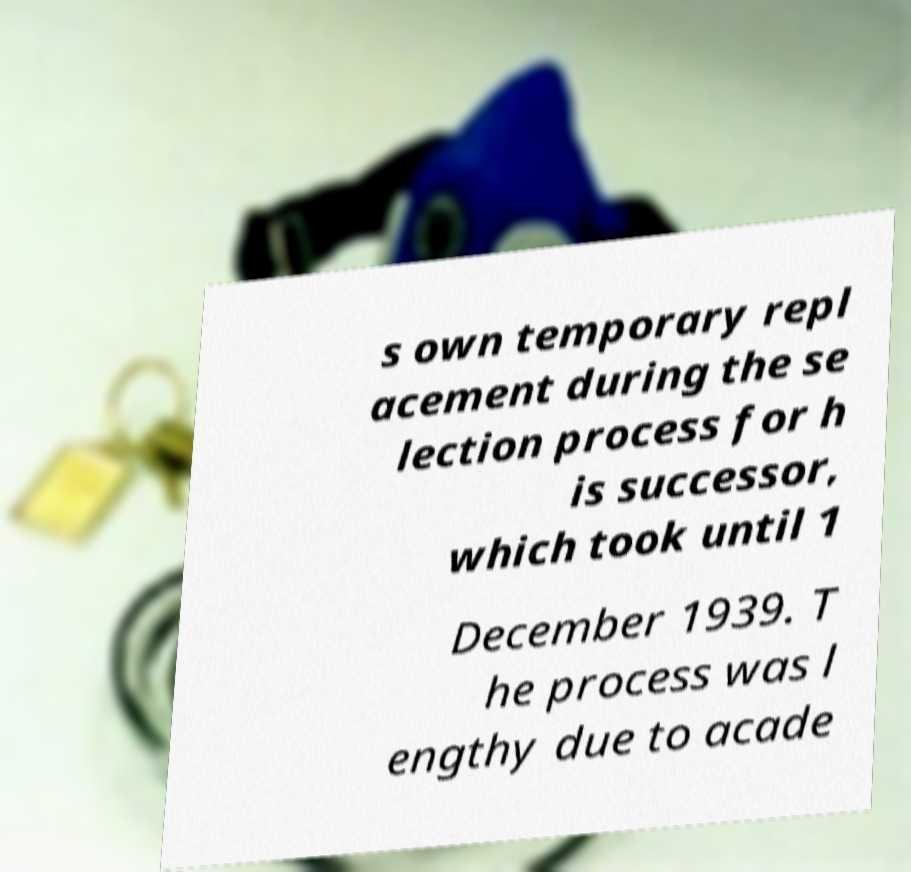Can you accurately transcribe the text from the provided image for me? s own temporary repl acement during the se lection process for h is successor, which took until 1 December 1939. T he process was l engthy due to acade 